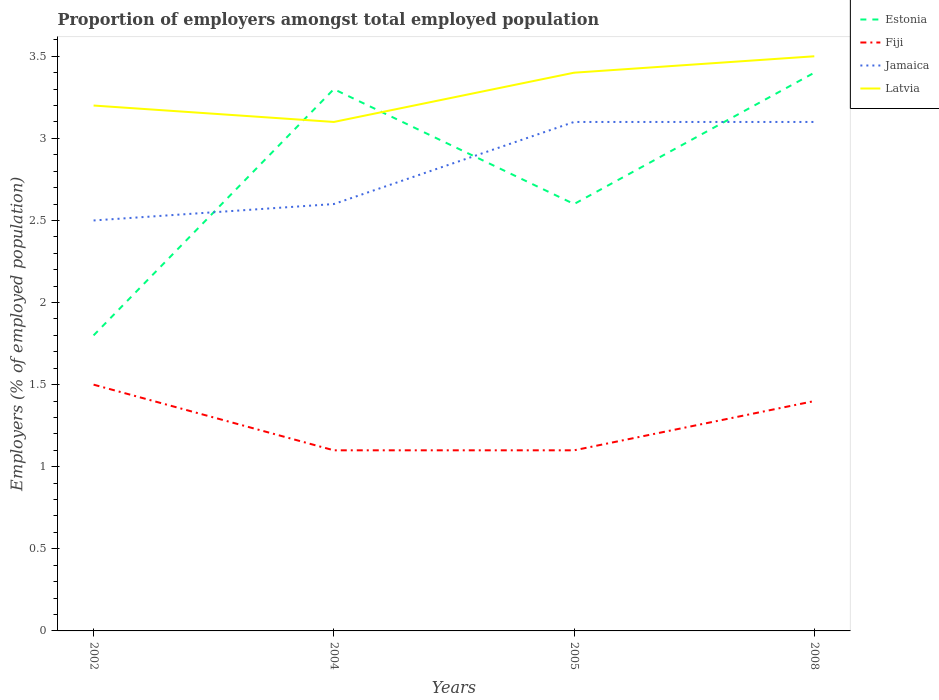How many different coloured lines are there?
Offer a very short reply. 4. Does the line corresponding to Latvia intersect with the line corresponding to Fiji?
Make the answer very short. No. Is the number of lines equal to the number of legend labels?
Make the answer very short. Yes. Across all years, what is the maximum proportion of employers in Fiji?
Provide a short and direct response. 1.1. What is the difference between the highest and the second highest proportion of employers in Fiji?
Offer a very short reply. 0.4. How many years are there in the graph?
Provide a succinct answer. 4. What is the difference between two consecutive major ticks on the Y-axis?
Your answer should be very brief. 0.5. What is the title of the graph?
Keep it short and to the point. Proportion of employers amongst total employed population. Does "Bahamas" appear as one of the legend labels in the graph?
Offer a very short reply. No. What is the label or title of the Y-axis?
Your response must be concise. Employers (% of employed population). What is the Employers (% of employed population) in Estonia in 2002?
Provide a succinct answer. 1.8. What is the Employers (% of employed population) of Latvia in 2002?
Ensure brevity in your answer.  3.2. What is the Employers (% of employed population) of Estonia in 2004?
Give a very brief answer. 3.3. What is the Employers (% of employed population) of Fiji in 2004?
Give a very brief answer. 1.1. What is the Employers (% of employed population) in Jamaica in 2004?
Offer a terse response. 2.6. What is the Employers (% of employed population) of Latvia in 2004?
Make the answer very short. 3.1. What is the Employers (% of employed population) in Estonia in 2005?
Provide a succinct answer. 2.6. What is the Employers (% of employed population) in Fiji in 2005?
Offer a very short reply. 1.1. What is the Employers (% of employed population) in Jamaica in 2005?
Your answer should be very brief. 3.1. What is the Employers (% of employed population) of Latvia in 2005?
Ensure brevity in your answer.  3.4. What is the Employers (% of employed population) in Estonia in 2008?
Ensure brevity in your answer.  3.4. What is the Employers (% of employed population) in Fiji in 2008?
Your answer should be compact. 1.4. What is the Employers (% of employed population) in Jamaica in 2008?
Your answer should be compact. 3.1. What is the Employers (% of employed population) in Latvia in 2008?
Ensure brevity in your answer.  3.5. Across all years, what is the maximum Employers (% of employed population) of Estonia?
Your response must be concise. 3.4. Across all years, what is the maximum Employers (% of employed population) of Fiji?
Offer a terse response. 1.5. Across all years, what is the maximum Employers (% of employed population) in Jamaica?
Make the answer very short. 3.1. Across all years, what is the maximum Employers (% of employed population) of Latvia?
Provide a short and direct response. 3.5. Across all years, what is the minimum Employers (% of employed population) in Estonia?
Provide a succinct answer. 1.8. Across all years, what is the minimum Employers (% of employed population) in Fiji?
Make the answer very short. 1.1. Across all years, what is the minimum Employers (% of employed population) in Latvia?
Provide a succinct answer. 3.1. What is the total Employers (% of employed population) of Estonia in the graph?
Ensure brevity in your answer.  11.1. What is the total Employers (% of employed population) in Latvia in the graph?
Make the answer very short. 13.2. What is the difference between the Employers (% of employed population) in Fiji in 2002 and that in 2004?
Give a very brief answer. 0.4. What is the difference between the Employers (% of employed population) of Jamaica in 2002 and that in 2004?
Your answer should be very brief. -0.1. What is the difference between the Employers (% of employed population) of Latvia in 2002 and that in 2004?
Your response must be concise. 0.1. What is the difference between the Employers (% of employed population) of Estonia in 2002 and that in 2005?
Make the answer very short. -0.8. What is the difference between the Employers (% of employed population) in Fiji in 2002 and that in 2005?
Your answer should be compact. 0.4. What is the difference between the Employers (% of employed population) in Estonia in 2002 and that in 2008?
Ensure brevity in your answer.  -1.6. What is the difference between the Employers (% of employed population) of Fiji in 2002 and that in 2008?
Your response must be concise. 0.1. What is the difference between the Employers (% of employed population) in Jamaica in 2002 and that in 2008?
Keep it short and to the point. -0.6. What is the difference between the Employers (% of employed population) in Latvia in 2002 and that in 2008?
Ensure brevity in your answer.  -0.3. What is the difference between the Employers (% of employed population) of Jamaica in 2004 and that in 2005?
Your answer should be very brief. -0.5. What is the difference between the Employers (% of employed population) in Latvia in 2004 and that in 2005?
Offer a very short reply. -0.3. What is the difference between the Employers (% of employed population) of Jamaica in 2004 and that in 2008?
Provide a short and direct response. -0.5. What is the difference between the Employers (% of employed population) in Estonia in 2005 and that in 2008?
Ensure brevity in your answer.  -0.8. What is the difference between the Employers (% of employed population) in Fiji in 2005 and that in 2008?
Your answer should be compact. -0.3. What is the difference between the Employers (% of employed population) in Jamaica in 2005 and that in 2008?
Ensure brevity in your answer.  0. What is the difference between the Employers (% of employed population) of Estonia in 2002 and the Employers (% of employed population) of Fiji in 2004?
Provide a short and direct response. 0.7. What is the difference between the Employers (% of employed population) of Estonia in 2002 and the Employers (% of employed population) of Jamaica in 2004?
Keep it short and to the point. -0.8. What is the difference between the Employers (% of employed population) of Estonia in 2002 and the Employers (% of employed population) of Latvia in 2004?
Ensure brevity in your answer.  -1.3. What is the difference between the Employers (% of employed population) in Jamaica in 2002 and the Employers (% of employed population) in Latvia in 2004?
Provide a short and direct response. -0.6. What is the difference between the Employers (% of employed population) of Estonia in 2002 and the Employers (% of employed population) of Fiji in 2005?
Give a very brief answer. 0.7. What is the difference between the Employers (% of employed population) in Estonia in 2002 and the Employers (% of employed population) in Jamaica in 2005?
Keep it short and to the point. -1.3. What is the difference between the Employers (% of employed population) of Estonia in 2002 and the Employers (% of employed population) of Latvia in 2005?
Your answer should be very brief. -1.6. What is the difference between the Employers (% of employed population) of Fiji in 2002 and the Employers (% of employed population) of Jamaica in 2005?
Offer a very short reply. -1.6. What is the difference between the Employers (% of employed population) in Jamaica in 2002 and the Employers (% of employed population) in Latvia in 2005?
Keep it short and to the point. -0.9. What is the difference between the Employers (% of employed population) in Estonia in 2002 and the Employers (% of employed population) in Fiji in 2008?
Your answer should be very brief. 0.4. What is the difference between the Employers (% of employed population) of Estonia in 2002 and the Employers (% of employed population) of Jamaica in 2008?
Your response must be concise. -1.3. What is the difference between the Employers (% of employed population) in Estonia in 2002 and the Employers (% of employed population) in Latvia in 2008?
Keep it short and to the point. -1.7. What is the difference between the Employers (% of employed population) of Jamaica in 2002 and the Employers (% of employed population) of Latvia in 2008?
Make the answer very short. -1. What is the difference between the Employers (% of employed population) of Estonia in 2004 and the Employers (% of employed population) of Fiji in 2005?
Your answer should be very brief. 2.2. What is the difference between the Employers (% of employed population) in Estonia in 2004 and the Employers (% of employed population) in Jamaica in 2005?
Give a very brief answer. 0.2. What is the difference between the Employers (% of employed population) of Fiji in 2004 and the Employers (% of employed population) of Latvia in 2005?
Your answer should be compact. -2.3. What is the difference between the Employers (% of employed population) in Jamaica in 2004 and the Employers (% of employed population) in Latvia in 2005?
Your answer should be very brief. -0.8. What is the difference between the Employers (% of employed population) in Estonia in 2004 and the Employers (% of employed population) in Latvia in 2008?
Ensure brevity in your answer.  -0.2. What is the difference between the Employers (% of employed population) in Fiji in 2004 and the Employers (% of employed population) in Latvia in 2008?
Provide a short and direct response. -2.4. What is the difference between the Employers (% of employed population) in Estonia in 2005 and the Employers (% of employed population) in Fiji in 2008?
Offer a very short reply. 1.2. What is the difference between the Employers (% of employed population) in Estonia in 2005 and the Employers (% of employed population) in Latvia in 2008?
Give a very brief answer. -0.9. What is the average Employers (% of employed population) of Estonia per year?
Offer a terse response. 2.77. What is the average Employers (% of employed population) of Fiji per year?
Give a very brief answer. 1.27. What is the average Employers (% of employed population) of Jamaica per year?
Your answer should be compact. 2.83. What is the average Employers (% of employed population) in Latvia per year?
Your response must be concise. 3.3. In the year 2002, what is the difference between the Employers (% of employed population) in Estonia and Employers (% of employed population) in Fiji?
Give a very brief answer. 0.3. In the year 2002, what is the difference between the Employers (% of employed population) in Estonia and Employers (% of employed population) in Jamaica?
Offer a very short reply. -0.7. In the year 2002, what is the difference between the Employers (% of employed population) in Estonia and Employers (% of employed population) in Latvia?
Your response must be concise. -1.4. In the year 2002, what is the difference between the Employers (% of employed population) of Jamaica and Employers (% of employed population) of Latvia?
Your answer should be compact. -0.7. In the year 2004, what is the difference between the Employers (% of employed population) in Estonia and Employers (% of employed population) in Latvia?
Make the answer very short. 0.2. In the year 2005, what is the difference between the Employers (% of employed population) of Estonia and Employers (% of employed population) of Latvia?
Ensure brevity in your answer.  -0.8. In the year 2005, what is the difference between the Employers (% of employed population) of Fiji and Employers (% of employed population) of Latvia?
Your response must be concise. -2.3. In the year 2005, what is the difference between the Employers (% of employed population) in Jamaica and Employers (% of employed population) in Latvia?
Offer a very short reply. -0.3. In the year 2008, what is the difference between the Employers (% of employed population) in Estonia and Employers (% of employed population) in Jamaica?
Offer a very short reply. 0.3. In the year 2008, what is the difference between the Employers (% of employed population) of Estonia and Employers (% of employed population) of Latvia?
Your response must be concise. -0.1. In the year 2008, what is the difference between the Employers (% of employed population) of Jamaica and Employers (% of employed population) of Latvia?
Make the answer very short. -0.4. What is the ratio of the Employers (% of employed population) of Estonia in 2002 to that in 2004?
Provide a short and direct response. 0.55. What is the ratio of the Employers (% of employed population) of Fiji in 2002 to that in 2004?
Provide a short and direct response. 1.36. What is the ratio of the Employers (% of employed population) in Jamaica in 2002 to that in 2004?
Provide a succinct answer. 0.96. What is the ratio of the Employers (% of employed population) in Latvia in 2002 to that in 2004?
Offer a very short reply. 1.03. What is the ratio of the Employers (% of employed population) in Estonia in 2002 to that in 2005?
Provide a short and direct response. 0.69. What is the ratio of the Employers (% of employed population) in Fiji in 2002 to that in 2005?
Your answer should be very brief. 1.36. What is the ratio of the Employers (% of employed population) of Jamaica in 2002 to that in 2005?
Keep it short and to the point. 0.81. What is the ratio of the Employers (% of employed population) in Latvia in 2002 to that in 2005?
Give a very brief answer. 0.94. What is the ratio of the Employers (% of employed population) in Estonia in 2002 to that in 2008?
Give a very brief answer. 0.53. What is the ratio of the Employers (% of employed population) of Fiji in 2002 to that in 2008?
Your response must be concise. 1.07. What is the ratio of the Employers (% of employed population) in Jamaica in 2002 to that in 2008?
Ensure brevity in your answer.  0.81. What is the ratio of the Employers (% of employed population) in Latvia in 2002 to that in 2008?
Ensure brevity in your answer.  0.91. What is the ratio of the Employers (% of employed population) in Estonia in 2004 to that in 2005?
Ensure brevity in your answer.  1.27. What is the ratio of the Employers (% of employed population) of Jamaica in 2004 to that in 2005?
Your answer should be very brief. 0.84. What is the ratio of the Employers (% of employed population) of Latvia in 2004 to that in 2005?
Provide a short and direct response. 0.91. What is the ratio of the Employers (% of employed population) in Estonia in 2004 to that in 2008?
Your answer should be very brief. 0.97. What is the ratio of the Employers (% of employed population) of Fiji in 2004 to that in 2008?
Offer a terse response. 0.79. What is the ratio of the Employers (% of employed population) of Jamaica in 2004 to that in 2008?
Your answer should be very brief. 0.84. What is the ratio of the Employers (% of employed population) of Latvia in 2004 to that in 2008?
Give a very brief answer. 0.89. What is the ratio of the Employers (% of employed population) of Estonia in 2005 to that in 2008?
Offer a terse response. 0.76. What is the ratio of the Employers (% of employed population) of Fiji in 2005 to that in 2008?
Ensure brevity in your answer.  0.79. What is the ratio of the Employers (% of employed population) in Latvia in 2005 to that in 2008?
Offer a terse response. 0.97. What is the difference between the highest and the second highest Employers (% of employed population) in Estonia?
Ensure brevity in your answer.  0.1. What is the difference between the highest and the second highest Employers (% of employed population) in Fiji?
Make the answer very short. 0.1. What is the difference between the highest and the second highest Employers (% of employed population) of Jamaica?
Your answer should be compact. 0. What is the difference between the highest and the second highest Employers (% of employed population) in Latvia?
Your answer should be compact. 0.1. What is the difference between the highest and the lowest Employers (% of employed population) of Estonia?
Ensure brevity in your answer.  1.6. What is the difference between the highest and the lowest Employers (% of employed population) of Jamaica?
Provide a short and direct response. 0.6. 